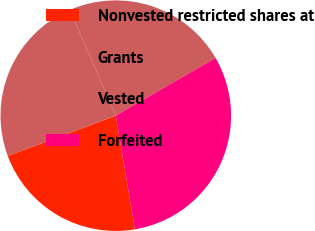Convert chart to OTSL. <chart><loc_0><loc_0><loc_500><loc_500><pie_chart><fcel>Nonvested restricted shares at<fcel>Grants<fcel>Vested<fcel>Forfeited<nl><fcel>21.98%<fcel>24.15%<fcel>23.18%<fcel>30.69%<nl></chart> 